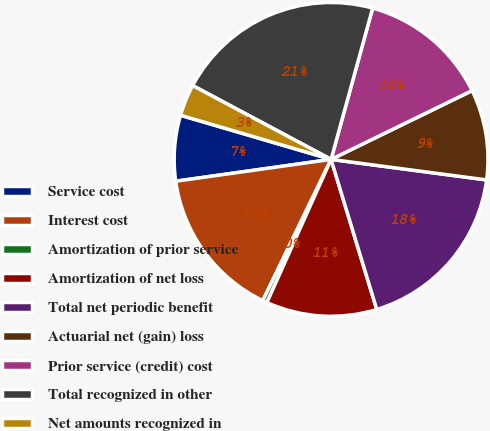<chart> <loc_0><loc_0><loc_500><loc_500><pie_chart><fcel>Service cost<fcel>Interest cost<fcel>Amortization of prior service<fcel>Amortization of net loss<fcel>Total net periodic benefit<fcel>Actuarial net (gain) loss<fcel>Prior service (credit) cost<fcel>Total recognized in other<fcel>Net amounts recognized in<nl><fcel>6.76%<fcel>15.61%<fcel>0.46%<fcel>11.41%<fcel>18.21%<fcel>9.31%<fcel>13.51%<fcel>21.47%<fcel>3.26%<nl></chart> 